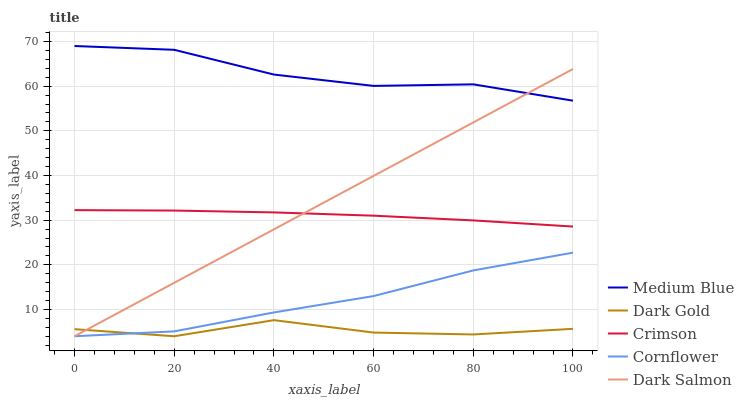Does Dark Gold have the minimum area under the curve?
Answer yes or no. Yes. Does Medium Blue have the maximum area under the curve?
Answer yes or no. Yes. Does Cornflower have the minimum area under the curve?
Answer yes or no. No. Does Cornflower have the maximum area under the curve?
Answer yes or no. No. Is Dark Salmon the smoothest?
Answer yes or no. Yes. Is Dark Gold the roughest?
Answer yes or no. Yes. Is Cornflower the smoothest?
Answer yes or no. No. Is Cornflower the roughest?
Answer yes or no. No. Does Cornflower have the lowest value?
Answer yes or no. Yes. Does Medium Blue have the lowest value?
Answer yes or no. No. Does Medium Blue have the highest value?
Answer yes or no. Yes. Does Cornflower have the highest value?
Answer yes or no. No. Is Cornflower less than Medium Blue?
Answer yes or no. Yes. Is Medium Blue greater than Cornflower?
Answer yes or no. Yes. Does Cornflower intersect Dark Salmon?
Answer yes or no. Yes. Is Cornflower less than Dark Salmon?
Answer yes or no. No. Is Cornflower greater than Dark Salmon?
Answer yes or no. No. Does Cornflower intersect Medium Blue?
Answer yes or no. No. 